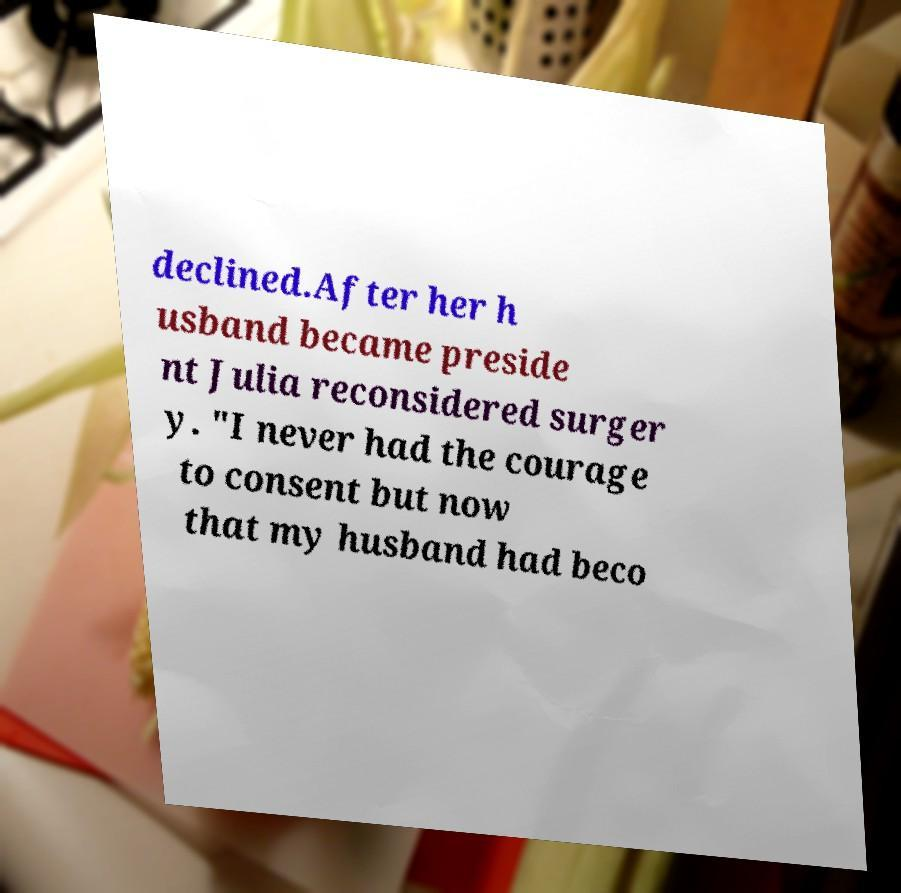Could you extract and type out the text from this image? declined.After her h usband became preside nt Julia reconsidered surger y. "I never had the courage to consent but now that my husband had beco 